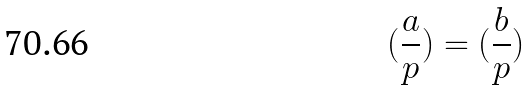<formula> <loc_0><loc_0><loc_500><loc_500>( \frac { a } { p } ) = ( \frac { b } { p } )</formula> 